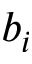Convert formula to latex. <formula><loc_0><loc_0><loc_500><loc_500>b _ { i }</formula> 